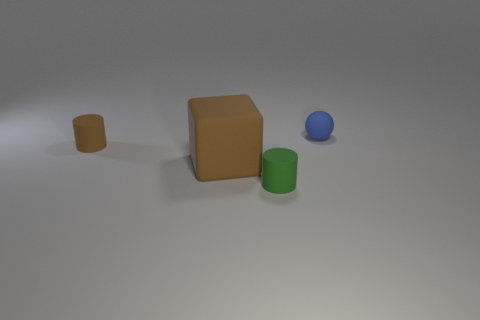Are there any other things that have the same size as the green thing?
Provide a succinct answer. Yes. What number of objects are purple matte spheres or balls?
Provide a short and direct response. 1. There is a rubber cylinder behind the cylinder right of the rubber cylinder left of the tiny green cylinder; what size is it?
Your answer should be very brief. Small. How many big rubber objects are the same color as the matte block?
Offer a very short reply. 0. What number of tiny cyan cubes have the same material as the tiny ball?
Your answer should be very brief. 0. What number of things are tiny yellow cylinders or things left of the big brown block?
Your answer should be very brief. 1. There is a small object that is in front of the object left of the large cube to the left of the tiny green cylinder; what is its color?
Give a very brief answer. Green. There is a thing that is to the right of the green matte cylinder; what is its size?
Offer a very short reply. Small. What number of tiny things are green matte cylinders or matte blocks?
Give a very brief answer. 1. The small rubber thing that is right of the large brown block and to the left of the tiny blue matte thing is what color?
Keep it short and to the point. Green. 